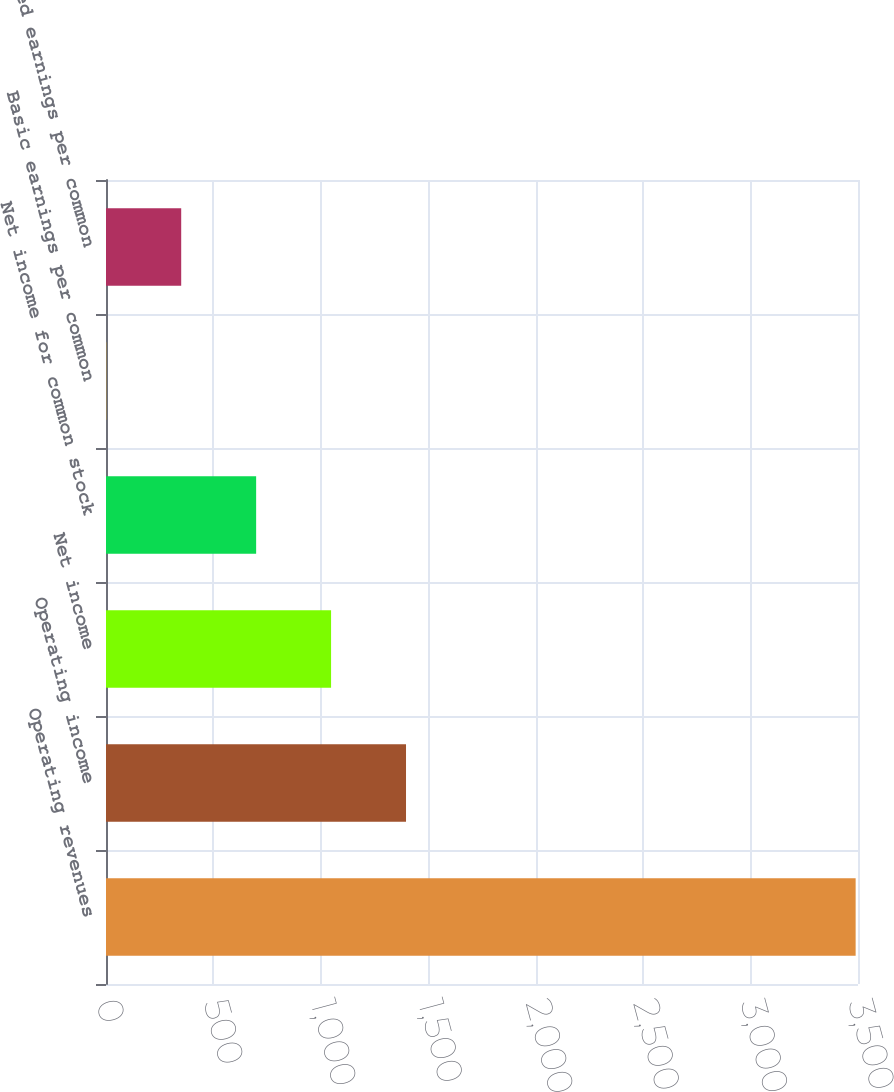Convert chart to OTSL. <chart><loc_0><loc_0><loc_500><loc_500><bar_chart><fcel>Operating revenues<fcel>Operating income<fcel>Net income<fcel>Net income for common stock<fcel>Basic earnings per common<fcel>Diluted earnings per common<nl><fcel>3489<fcel>1396.34<fcel>1047.56<fcel>698.78<fcel>1.22<fcel>350<nl></chart> 